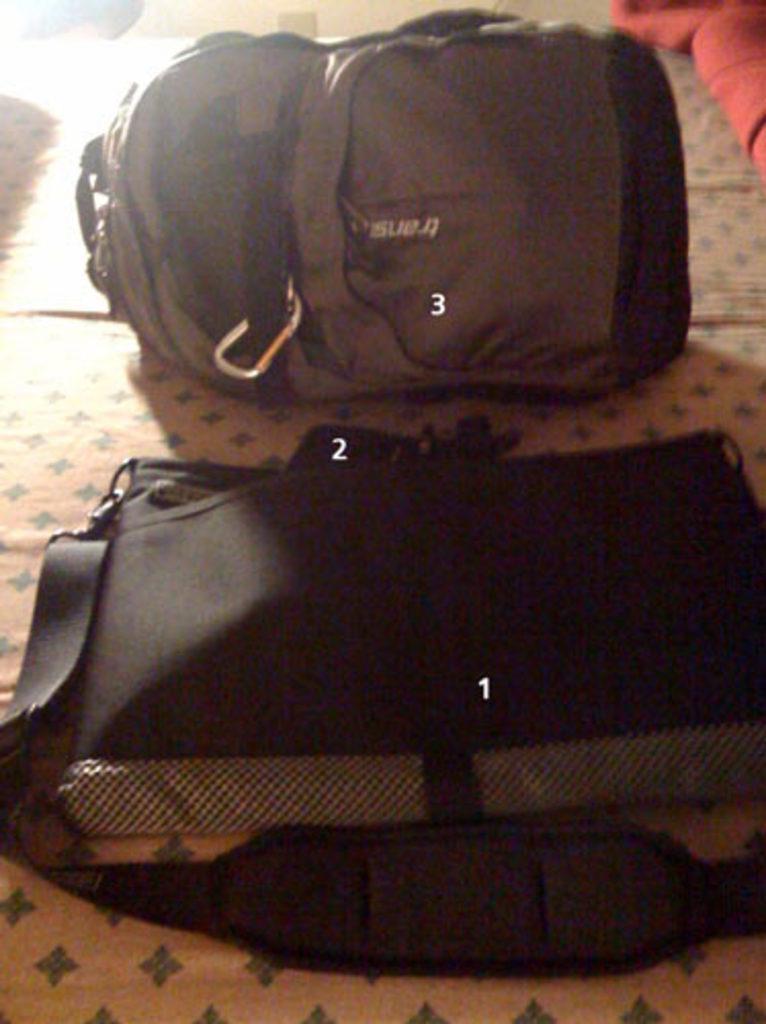Can you describe this image briefly? In the given image we can see some baggage. 